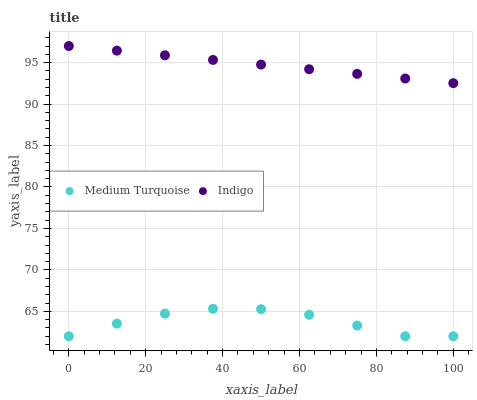Does Medium Turquoise have the minimum area under the curve?
Answer yes or no. Yes. Does Indigo have the maximum area under the curve?
Answer yes or no. Yes. Does Medium Turquoise have the maximum area under the curve?
Answer yes or no. No. Is Indigo the smoothest?
Answer yes or no. Yes. Is Medium Turquoise the roughest?
Answer yes or no. Yes. Is Medium Turquoise the smoothest?
Answer yes or no. No. Does Medium Turquoise have the lowest value?
Answer yes or no. Yes. Does Indigo have the highest value?
Answer yes or no. Yes. Does Medium Turquoise have the highest value?
Answer yes or no. No. Is Medium Turquoise less than Indigo?
Answer yes or no. Yes. Is Indigo greater than Medium Turquoise?
Answer yes or no. Yes. Does Medium Turquoise intersect Indigo?
Answer yes or no. No. 